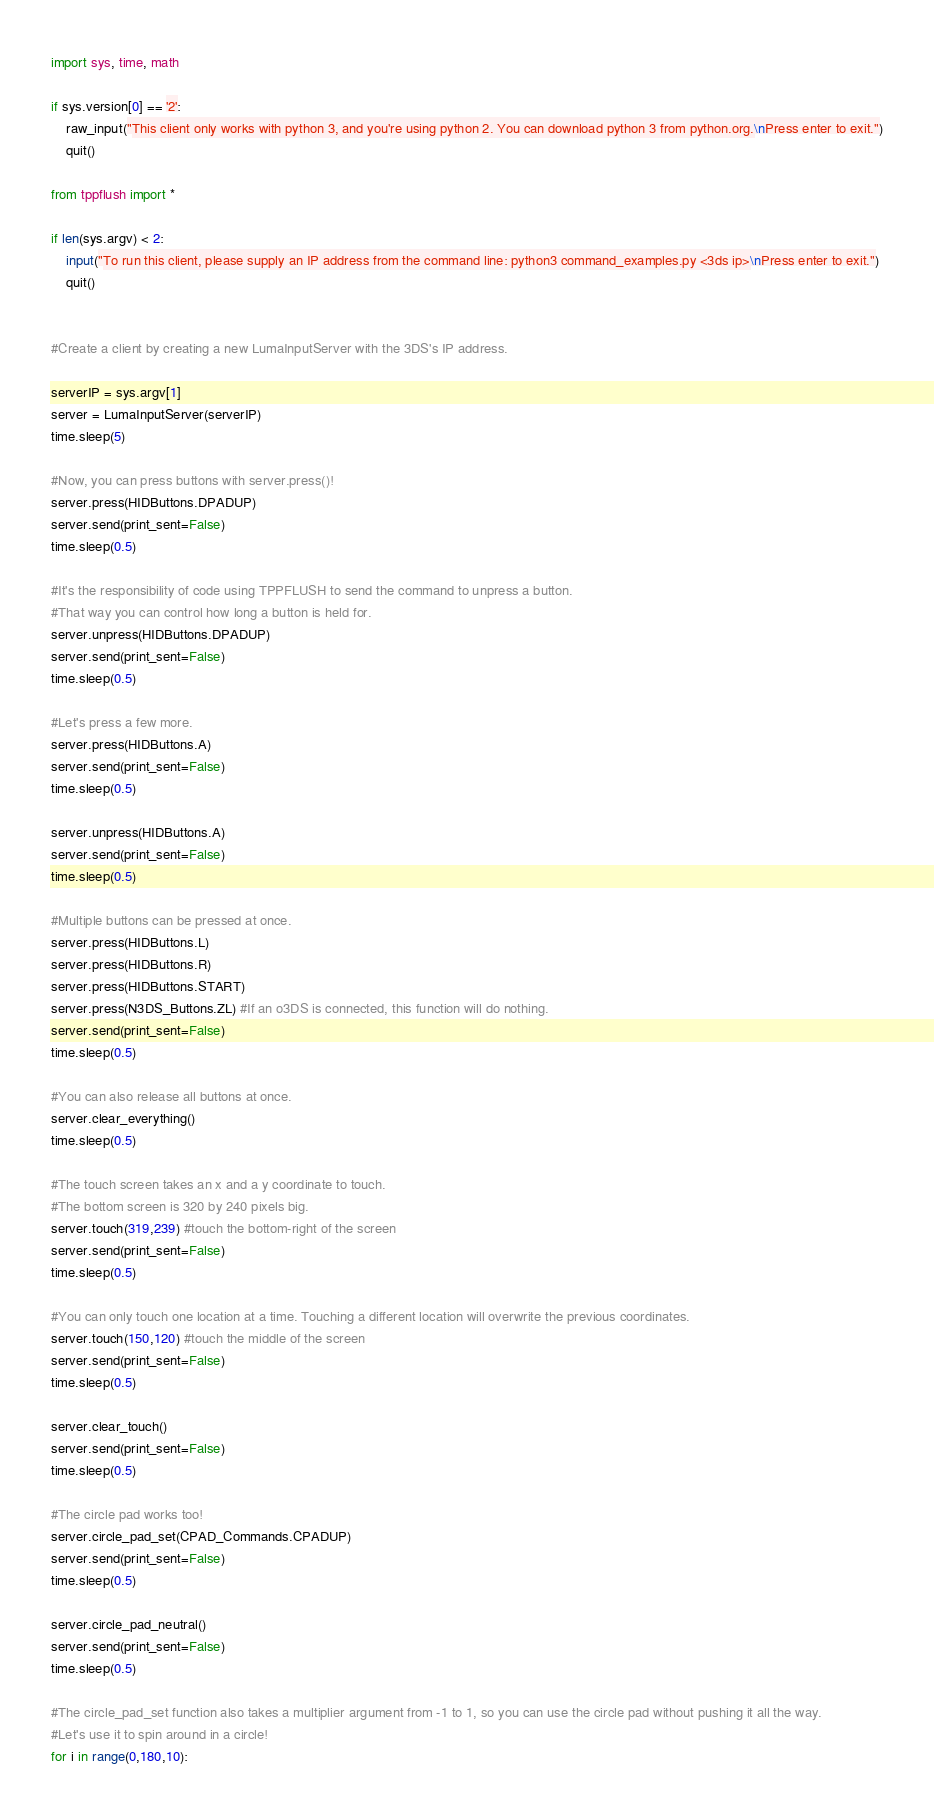Convert code to text. <code><loc_0><loc_0><loc_500><loc_500><_Python_>import sys, time, math

if sys.version[0] == '2':
	raw_input("This client only works with python 3, and you're using python 2. You can download python 3 from python.org.\nPress enter to exit.")
	quit()

from tppflush import *

if len(sys.argv) < 2:
	input("To run this client, please supply an IP address from the command line: python3 command_examples.py <3ds ip>\nPress enter to exit.")
	quit()


#Create a client by creating a new LumaInputServer with the 3DS's IP address.

serverIP = sys.argv[1]
server = LumaInputServer(serverIP)
time.sleep(5)

#Now, you can press buttons with server.press()!
server.press(HIDButtons.DPADUP)
server.send(print_sent=False)
time.sleep(0.5)

#It's the responsibility of code using TPPFLUSH to send the command to unpress a button.
#That way you can control how long a button is held for.
server.unpress(HIDButtons.DPADUP)
server.send(print_sent=False)
time.sleep(0.5)

#Let's press a few more.
server.press(HIDButtons.A)
server.send(print_sent=False)
time.sleep(0.5)

server.unpress(HIDButtons.A)
server.send(print_sent=False)
time.sleep(0.5)

#Multiple buttons can be pressed at once.
server.press(HIDButtons.L)
server.press(HIDButtons.R)
server.press(HIDButtons.START)
server.press(N3DS_Buttons.ZL) #If an o3DS is connected, this function will do nothing.
server.send(print_sent=False)
time.sleep(0.5)

#You can also release all buttons at once.
server.clear_everything()
time.sleep(0.5)

#The touch screen takes an x and a y coordinate to touch.
#The bottom screen is 320 by 240 pixels big.
server.touch(319,239) #touch the bottom-right of the screen
server.send(print_sent=False)
time.sleep(0.5)

#You can only touch one location at a time. Touching a different location will overwrite the previous coordinates.
server.touch(150,120) #touch the middle of the screen
server.send(print_sent=False)
time.sleep(0.5)

server.clear_touch()
server.send(print_sent=False)
time.sleep(0.5)

#The circle pad works too!
server.circle_pad_set(CPAD_Commands.CPADUP)
server.send(print_sent=False)
time.sleep(0.5)

server.circle_pad_neutral()
server.send(print_sent=False)
time.sleep(0.5)

#The circle_pad_set function also takes a multiplier argument from -1 to 1, so you can use the circle pad without pushing it all the way.
#Let's use it to spin around in a circle!
for i in range(0,180,10):</code> 